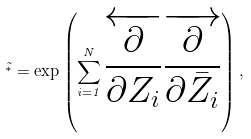Convert formula to latex. <formula><loc_0><loc_0><loc_500><loc_500>\tilde { ^ { * } } = \exp \left ( \sum _ { i = 1 } ^ { N } \overleftarrow { \frac { \partial } { \partial Z _ { i } } } \overrightarrow { \frac { \partial } { \partial { \bar { Z } _ { i } } } } \right ) ,</formula> 